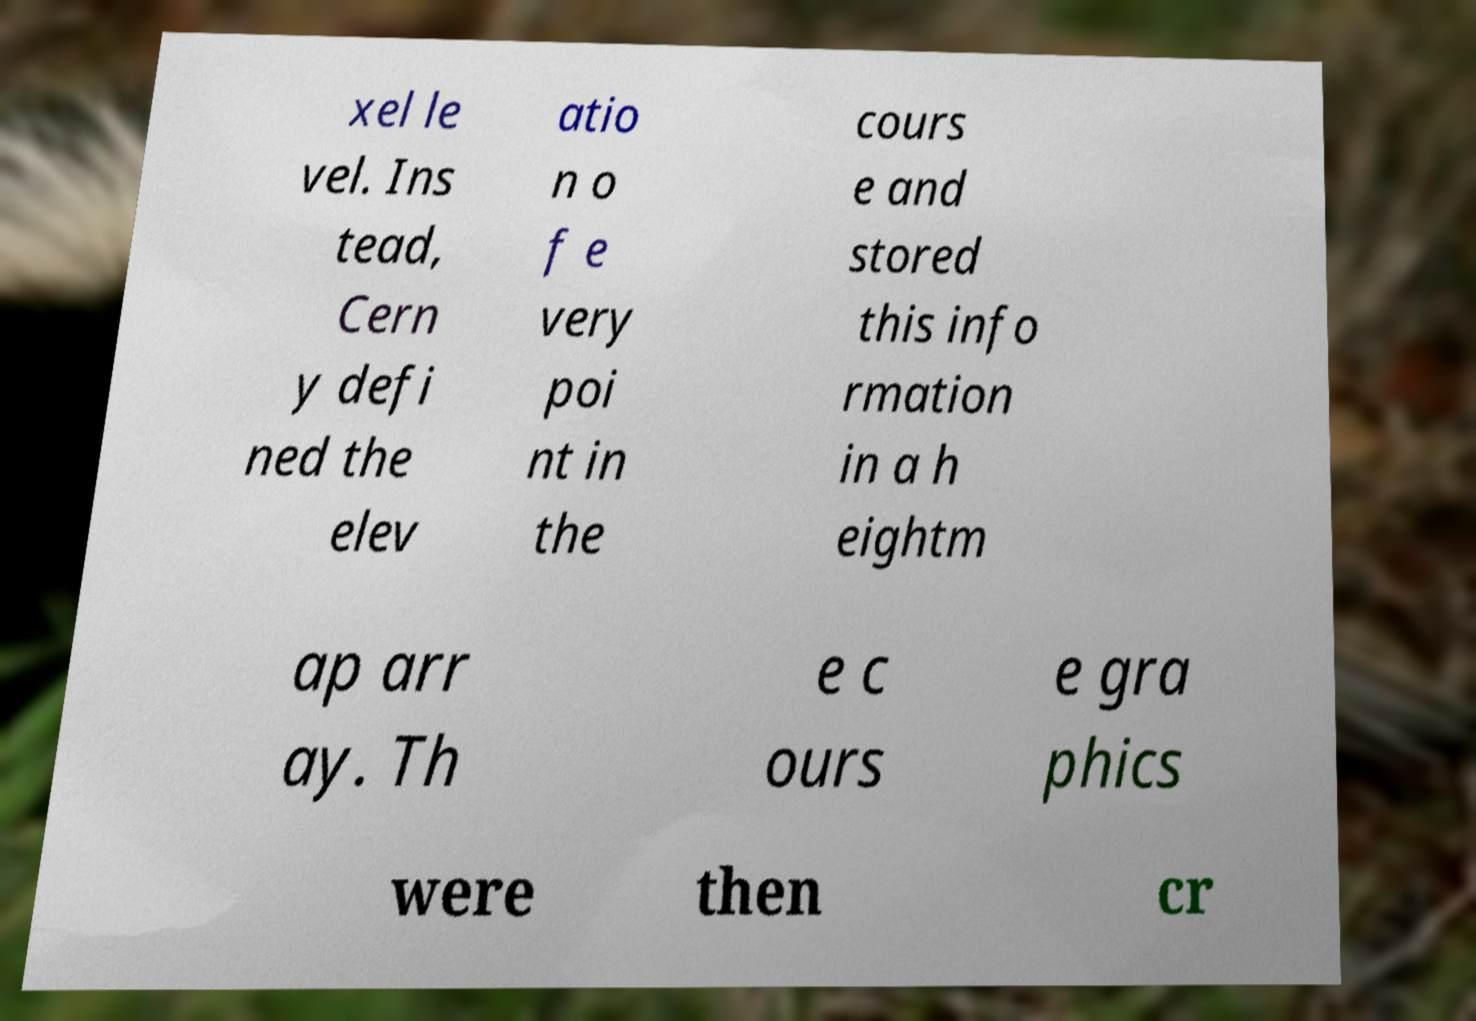Could you assist in decoding the text presented in this image and type it out clearly? xel le vel. Ins tead, Cern y defi ned the elev atio n o f e very poi nt in the cours e and stored this info rmation in a h eightm ap arr ay. Th e c ours e gra phics were then cr 